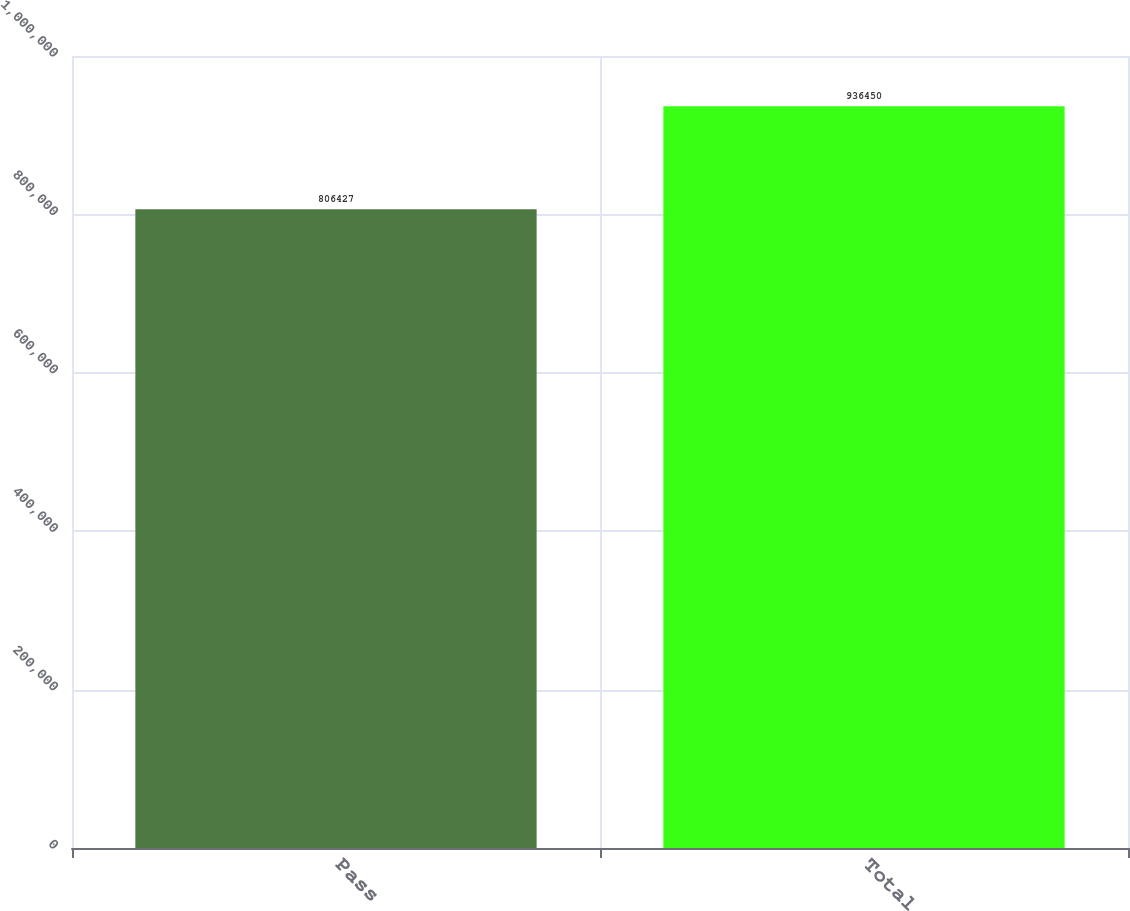<chart> <loc_0><loc_0><loc_500><loc_500><bar_chart><fcel>Pass<fcel>Total<nl><fcel>806427<fcel>936450<nl></chart> 